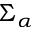<formula> <loc_0><loc_0><loc_500><loc_500>\Sigma _ { \alpha }</formula> 